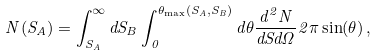<formula> <loc_0><loc_0><loc_500><loc_500>N ( S _ { A } ) = \int _ { S _ { A } } ^ { \infty } d S _ { B } \int _ { 0 } ^ { \theta _ { \max } ( S _ { A } , S _ { B } ) } d \theta \frac { d ^ { 2 } N } { d S d \Omega } 2 \pi \sin ( \theta ) \, ,</formula> 